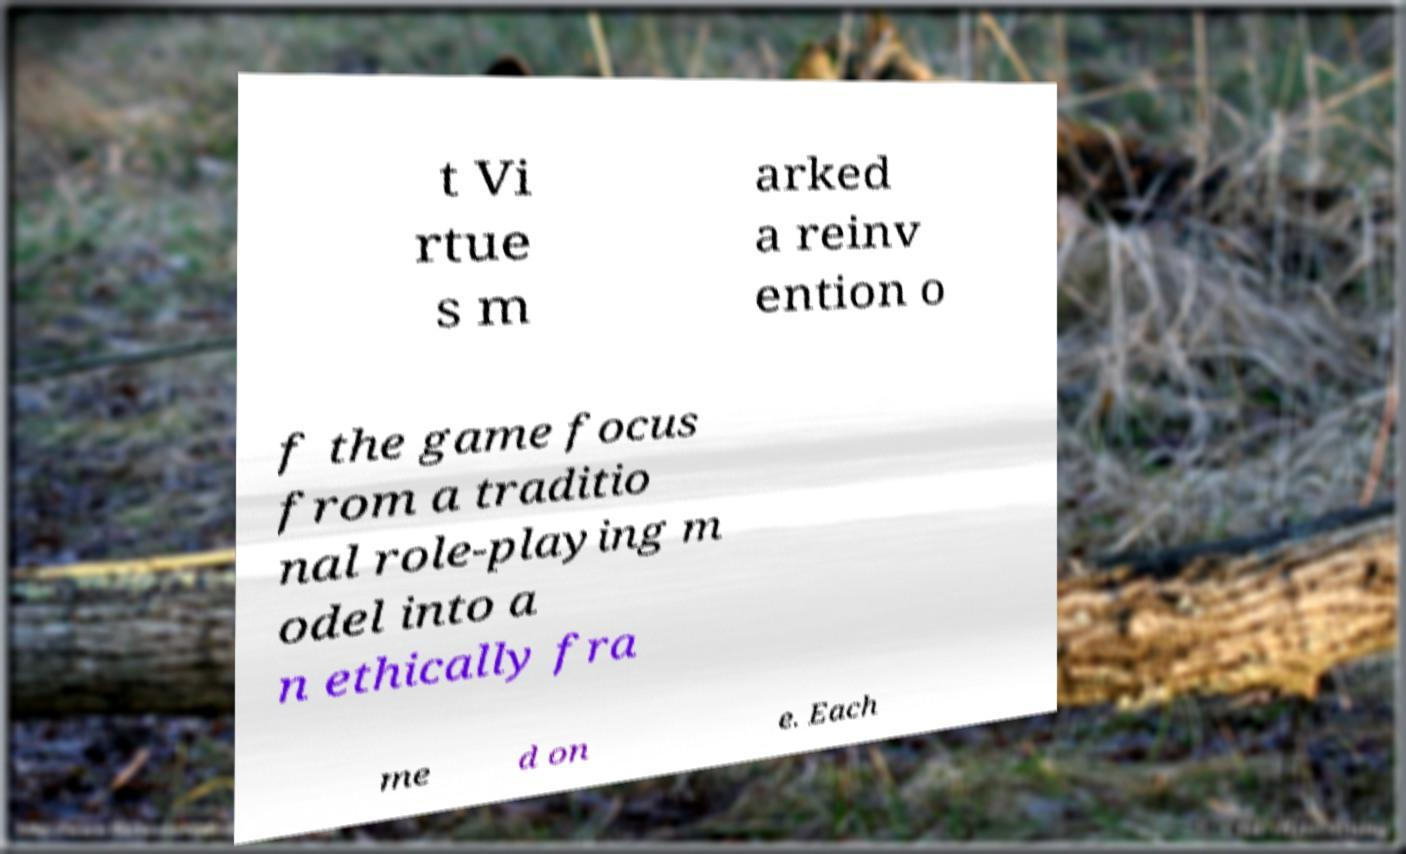Can you read and provide the text displayed in the image?This photo seems to have some interesting text. Can you extract and type it out for me? t Vi rtue s m arked a reinv ention o f the game focus from a traditio nal role-playing m odel into a n ethically fra me d on e. Each 